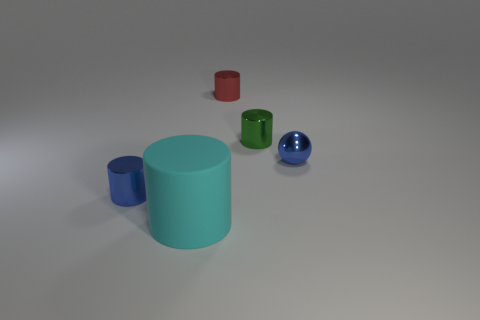Subtract 1 cylinders. How many cylinders are left? 3 Add 3 small green balls. How many objects exist? 8 Subtract all cylinders. How many objects are left? 1 Subtract 0 blue blocks. How many objects are left? 5 Subtract all tiny green things. Subtract all tiny red cylinders. How many objects are left? 3 Add 2 red things. How many red things are left? 3 Add 4 tiny blue metallic cylinders. How many tiny blue metallic cylinders exist? 5 